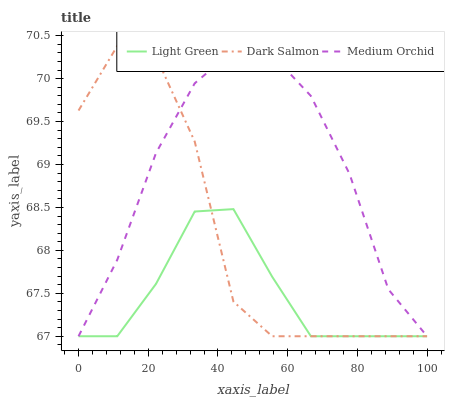Does Light Green have the minimum area under the curve?
Answer yes or no. Yes. Does Medium Orchid have the maximum area under the curve?
Answer yes or no. Yes. Does Dark Salmon have the minimum area under the curve?
Answer yes or no. No. Does Dark Salmon have the maximum area under the curve?
Answer yes or no. No. Is Light Green the smoothest?
Answer yes or no. Yes. Is Dark Salmon the roughest?
Answer yes or no. Yes. Is Dark Salmon the smoothest?
Answer yes or no. No. Is Light Green the roughest?
Answer yes or no. No. Does Medium Orchid have the lowest value?
Answer yes or no. Yes. Does Dark Salmon have the highest value?
Answer yes or no. Yes. Does Light Green have the highest value?
Answer yes or no. No. Does Dark Salmon intersect Medium Orchid?
Answer yes or no. Yes. Is Dark Salmon less than Medium Orchid?
Answer yes or no. No. Is Dark Salmon greater than Medium Orchid?
Answer yes or no. No. 